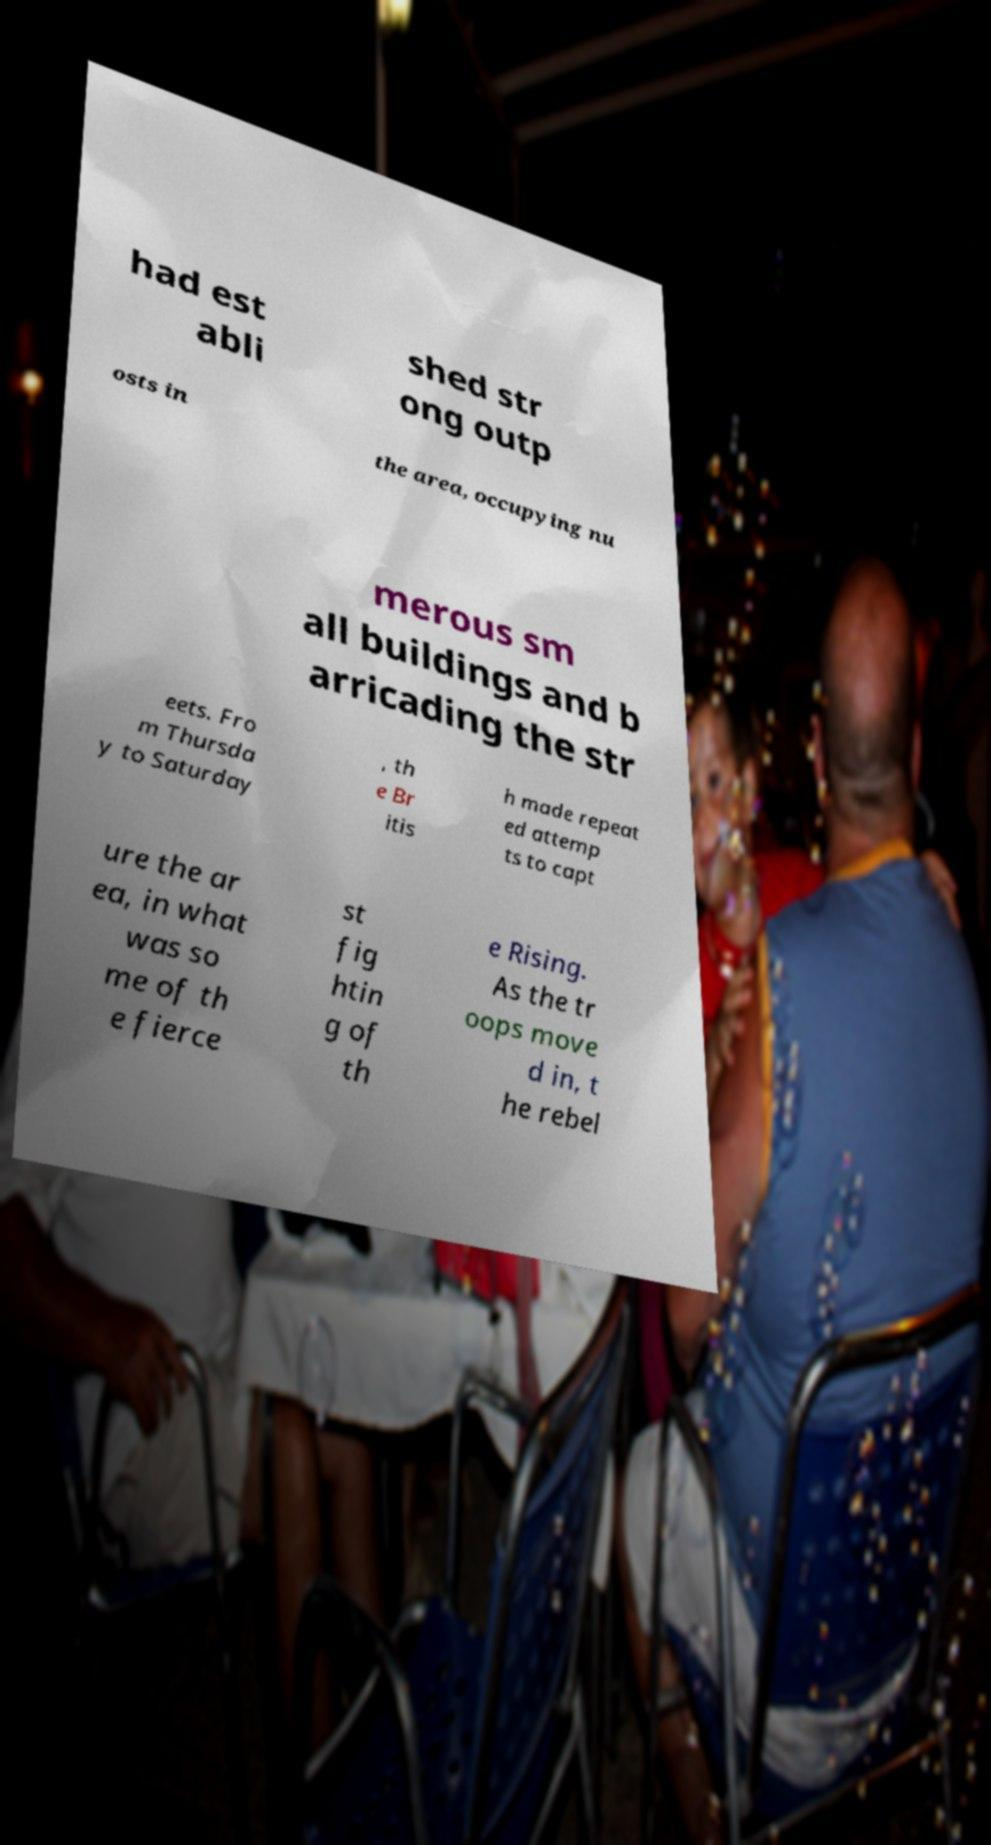Can you accurately transcribe the text from the provided image for me? had est abli shed str ong outp osts in the area, occupying nu merous sm all buildings and b arricading the str eets. Fro m Thursda y to Saturday , th e Br itis h made repeat ed attemp ts to capt ure the ar ea, in what was so me of th e fierce st fig htin g of th e Rising. As the tr oops move d in, t he rebel 